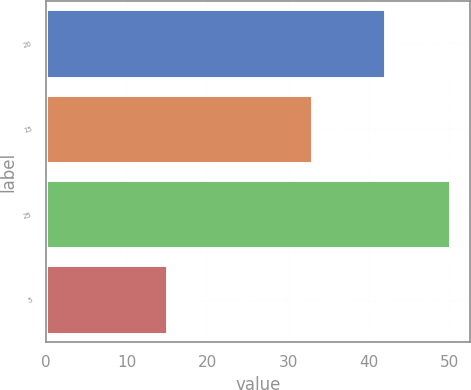Convert chart to OTSL. <chart><loc_0><loc_0><loc_500><loc_500><bar_chart><fcel>20<fcel>15<fcel>25<fcel>5<nl><fcel>42<fcel>33<fcel>50<fcel>15<nl></chart> 